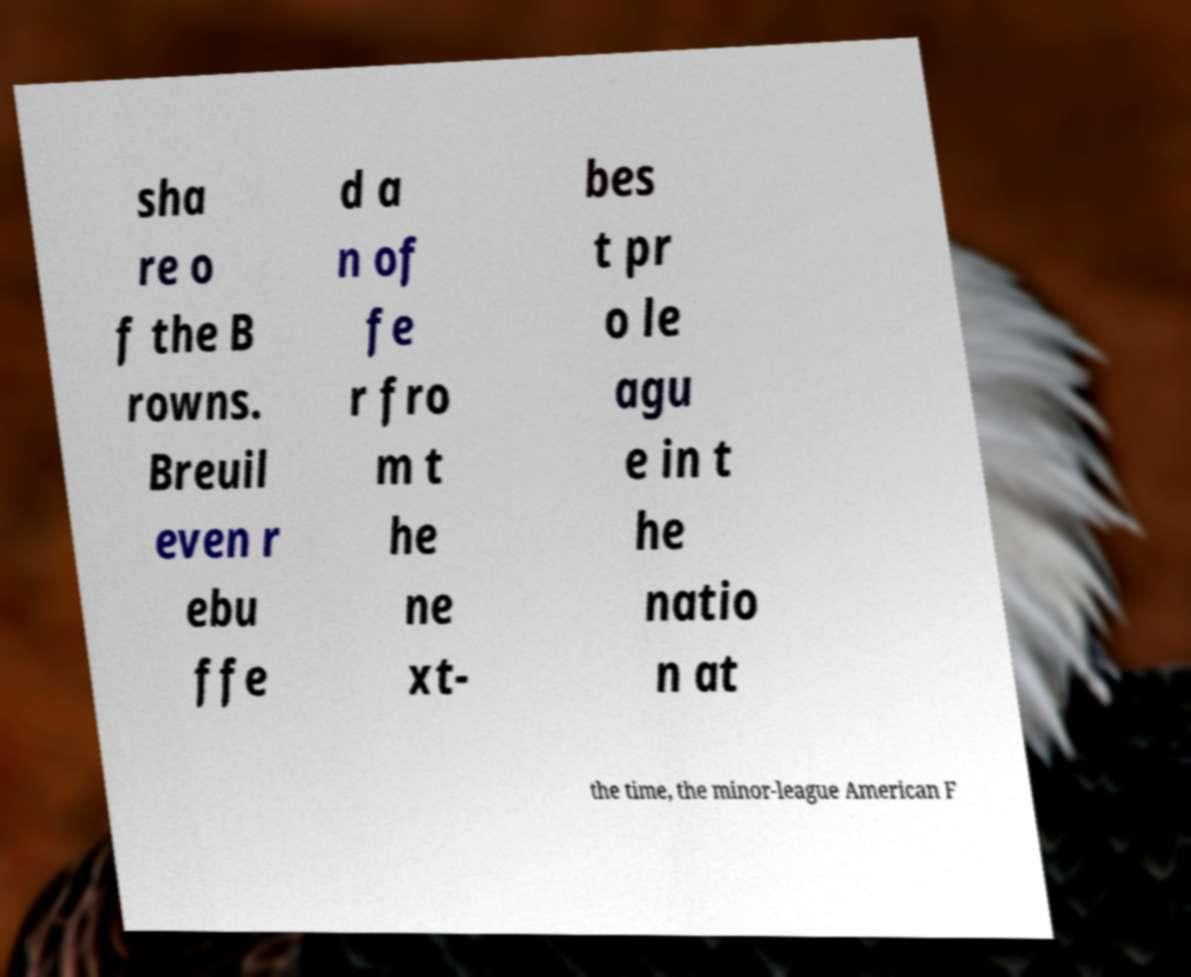Could you extract and type out the text from this image? sha re o f the B rowns. Breuil even r ebu ffe d a n of fe r fro m t he ne xt- bes t pr o le agu e in t he natio n at the time, the minor-league American F 